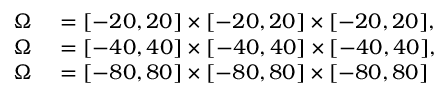Convert formula to latex. <formula><loc_0><loc_0><loc_500><loc_500>\begin{array} { r l } { \Omega } & = [ - 2 0 , 2 0 ] \times [ - 2 0 , 2 0 ] \times [ - 2 0 , 2 0 ] , } \\ { \Omega } & = [ - 4 0 , 4 0 ] \times [ - 4 0 , 4 0 ] \times [ - 4 0 , 4 0 ] , } \\ { \Omega } & = [ - 8 0 , 8 0 ] \times [ - 8 0 , 8 0 ] \times [ - 8 0 , 8 0 ] } \end{array}</formula> 